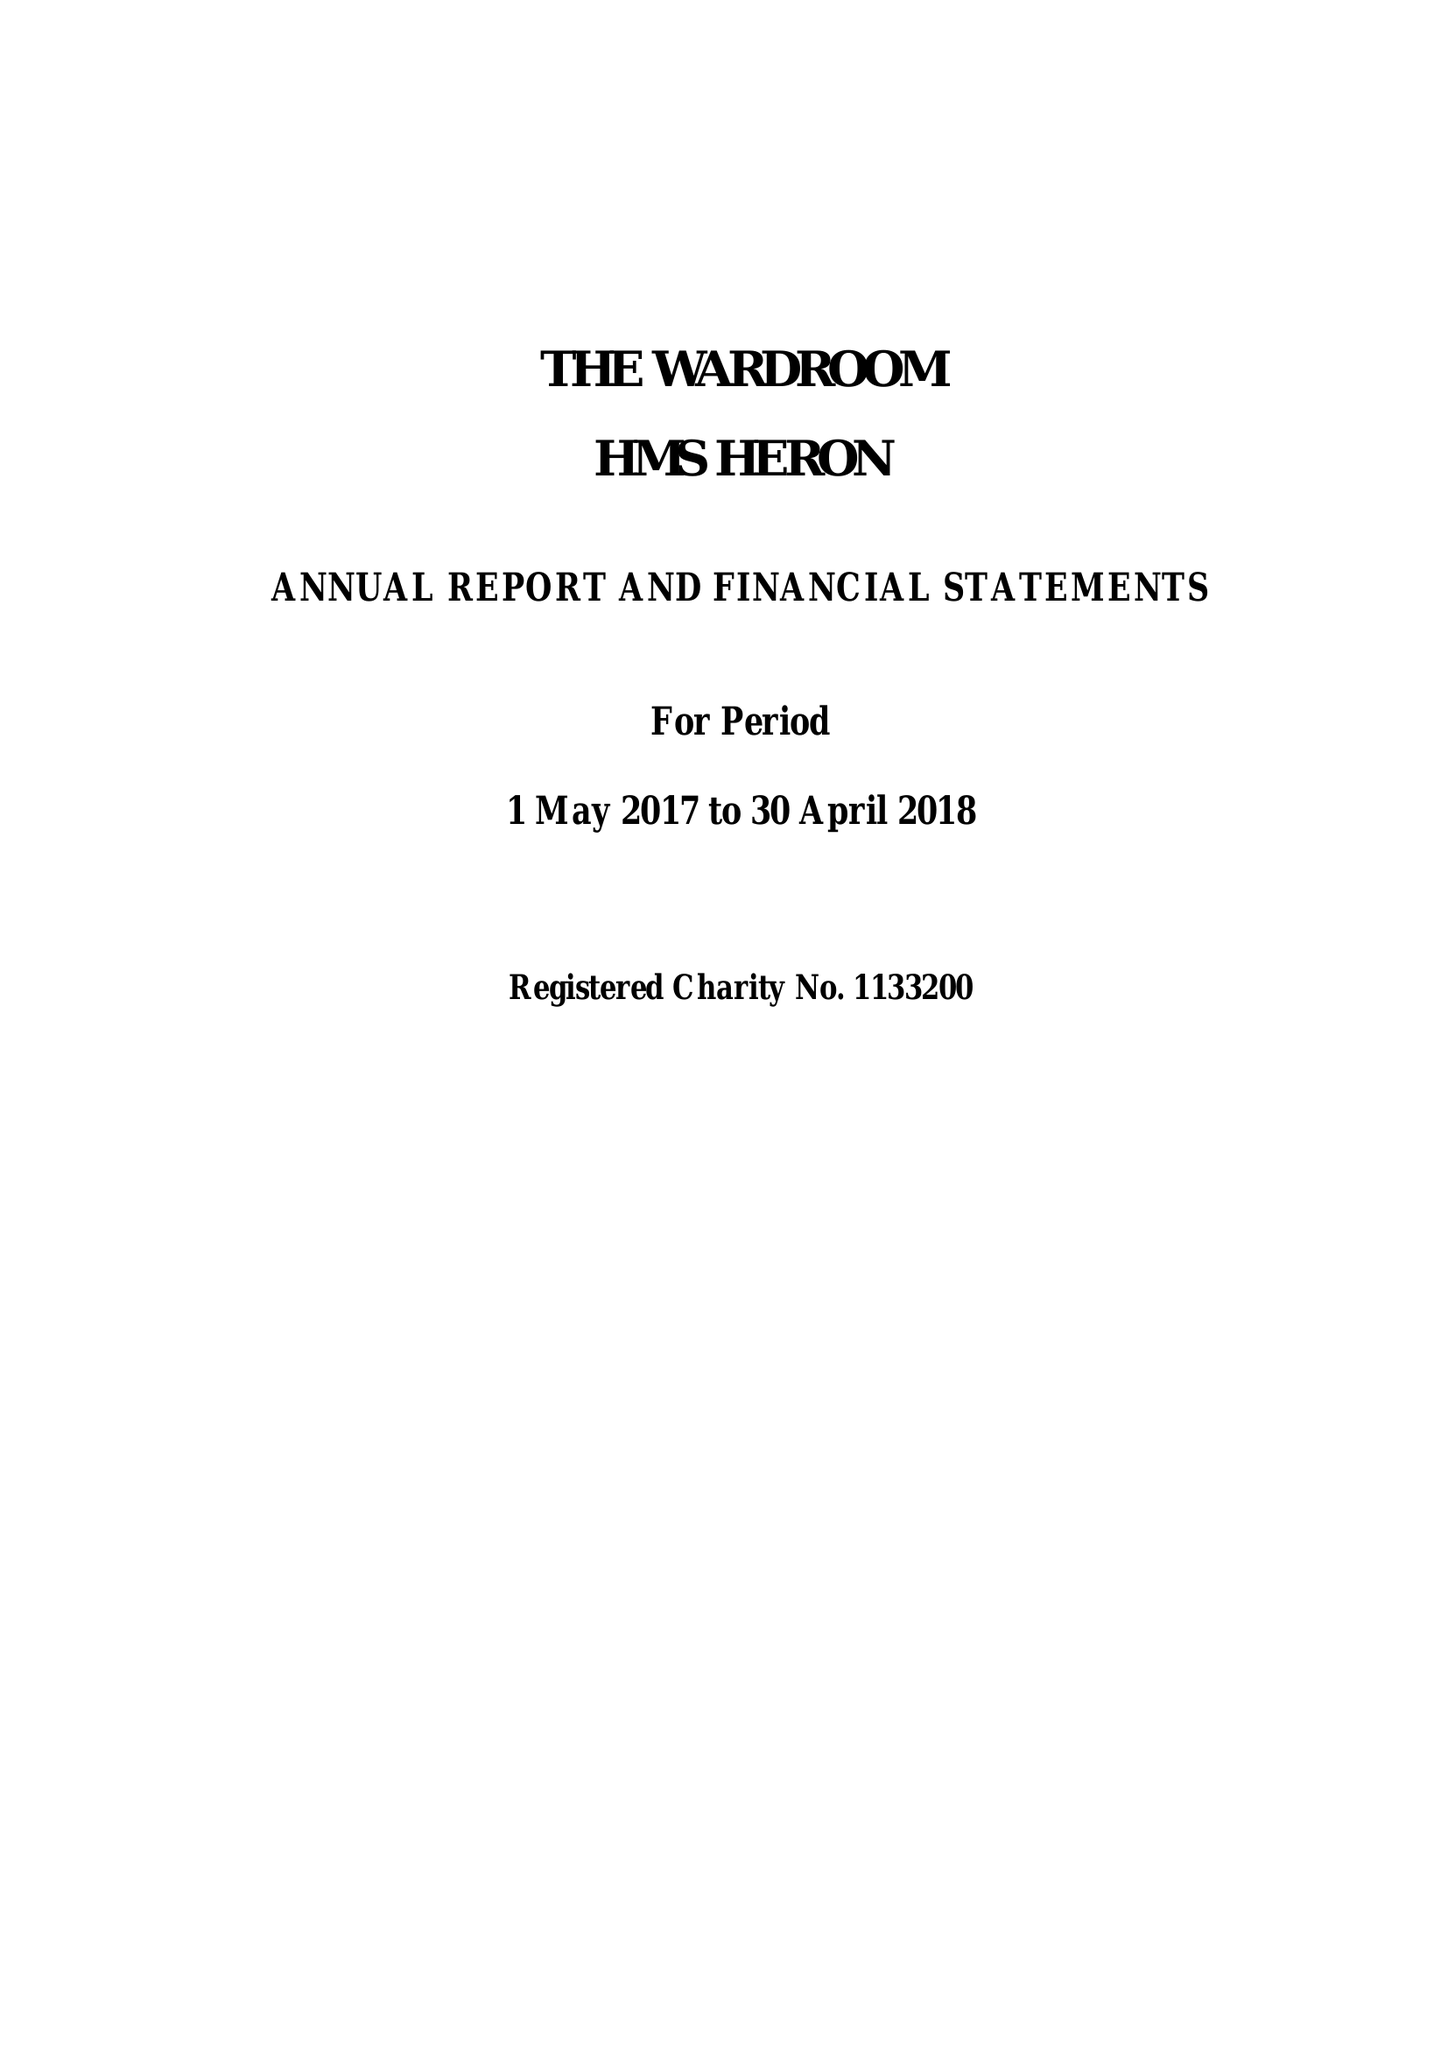What is the value for the spending_annually_in_british_pounds?
Answer the question using a single word or phrase. 229473.00 